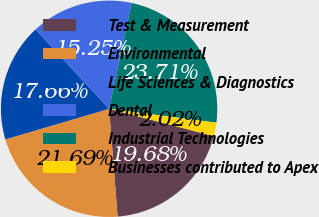Convert chart to OTSL. <chart><loc_0><loc_0><loc_500><loc_500><pie_chart><fcel>Test & Measurement<fcel>Environmental<fcel>Life Sciences & Diagnostics<fcel>Dental<fcel>Industrial Technologies<fcel>Businesses contributed to Apex<nl><fcel>19.68%<fcel>21.69%<fcel>17.66%<fcel>15.25%<fcel>23.71%<fcel>2.02%<nl></chart> 